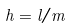<formula> <loc_0><loc_0><loc_500><loc_500>h = l / m</formula> 